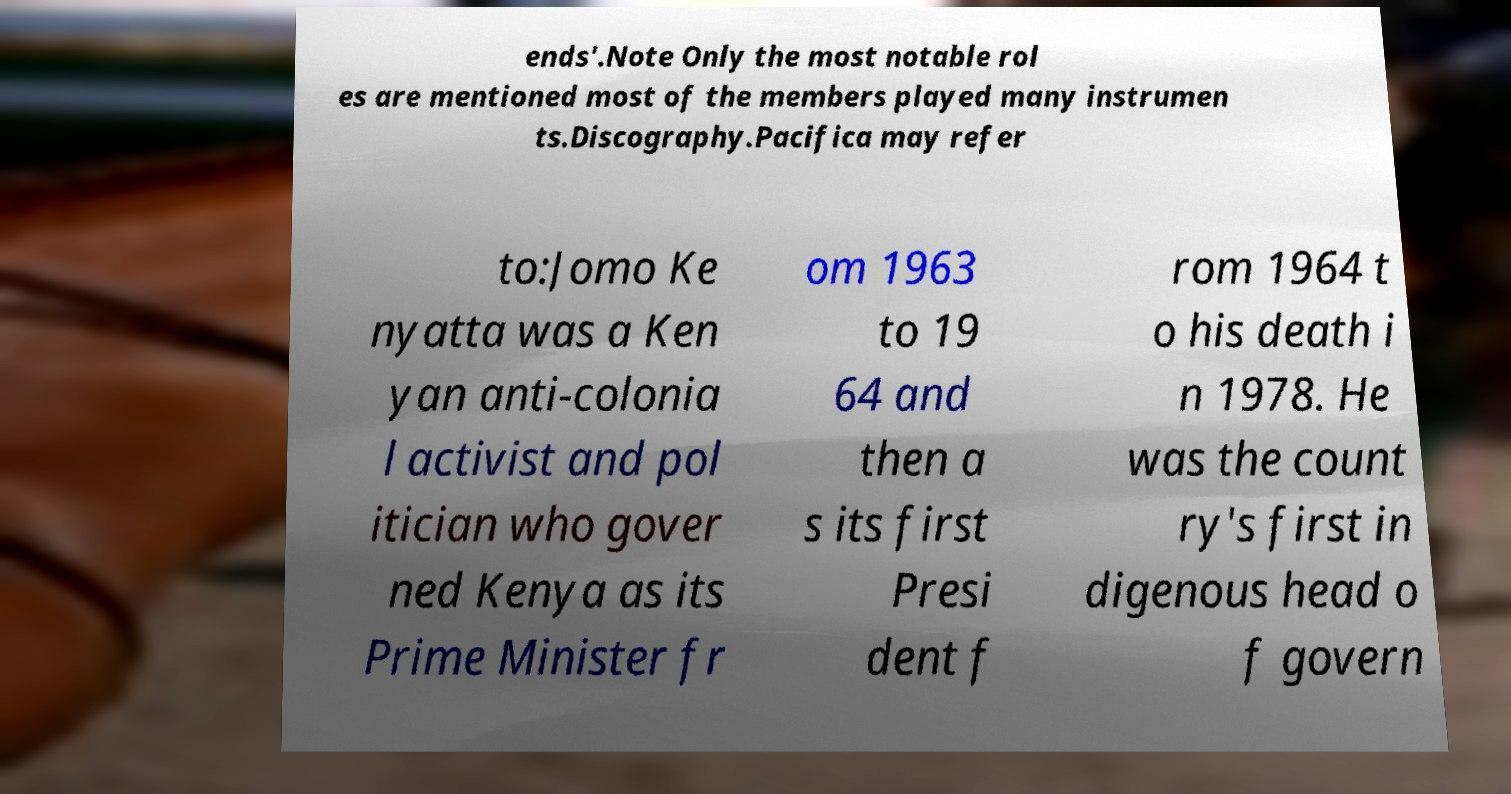Could you extract and type out the text from this image? ends'.Note Only the most notable rol es are mentioned most of the members played many instrumen ts.Discography.Pacifica may refer to:Jomo Ke nyatta was a Ken yan anti-colonia l activist and pol itician who gover ned Kenya as its Prime Minister fr om 1963 to 19 64 and then a s its first Presi dent f rom 1964 t o his death i n 1978. He was the count ry's first in digenous head o f govern 